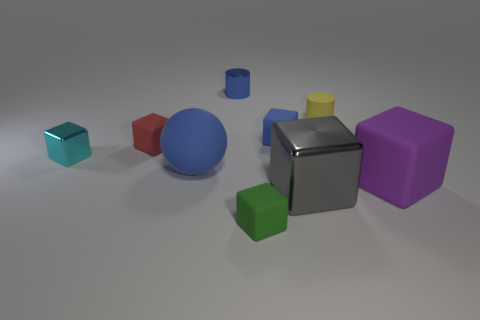What is the color of the big ball that is the same material as the tiny green block?
Make the answer very short. Blue. There is a blue object behind the blue rubber cube; how big is it?
Give a very brief answer. Small. There is a blue shiny thing; is its size the same as the shiny cube in front of the ball?
Your answer should be very brief. No. What is the color of the small rubber cube that is in front of the rubber cube right of the big metal object?
Provide a short and direct response. Green. How many other objects are there of the same color as the large sphere?
Your answer should be compact. 2. Is the number of things that are in front of the gray metal thing greater than the number of yellow cylinders on the right side of the tiny yellow rubber thing?
Give a very brief answer. Yes. How many red rubber objects are on the right side of the metallic thing that is right of the green thing?
Give a very brief answer. 0. Does the large thing that is in front of the purple block have the same shape as the tiny green thing?
Provide a succinct answer. Yes. What material is the purple object that is the same shape as the large gray metal thing?
Give a very brief answer. Rubber. There is a shiny thing that is on the right side of the cyan shiny thing and behind the large blue object; what is its color?
Keep it short and to the point. Blue. 